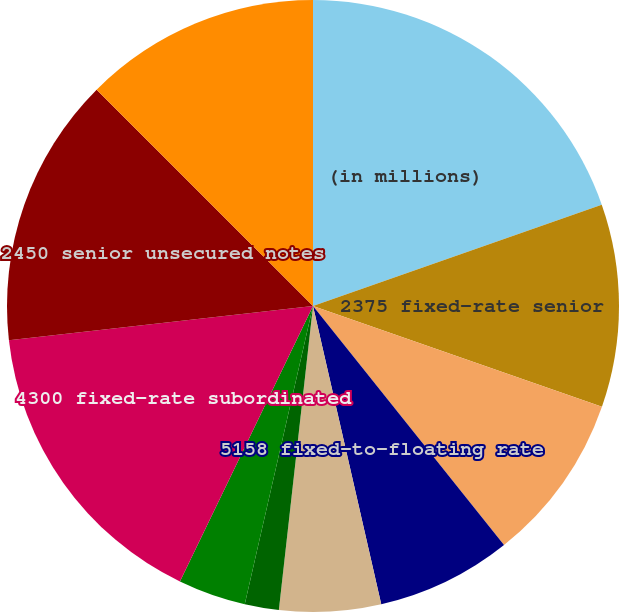<chart> <loc_0><loc_0><loc_500><loc_500><pie_chart><fcel>(in millions)<fcel>2375 fixed-rate senior<fcel>4150 fixed-rate subordinated<fcel>5158 fixed-to-floating rate<fcel>3750 fixed-rate subordinated<fcel>4023 fixed-rate subordinated<fcel>4350 fixed-rate subordinated<fcel>4300 fixed-rate subordinated<fcel>2450 senior unsecured notes<fcel>2500 senior unsecured notes<nl><fcel>19.63%<fcel>10.71%<fcel>8.93%<fcel>7.15%<fcel>5.36%<fcel>1.8%<fcel>3.58%<fcel>16.06%<fcel>14.28%<fcel>12.5%<nl></chart> 